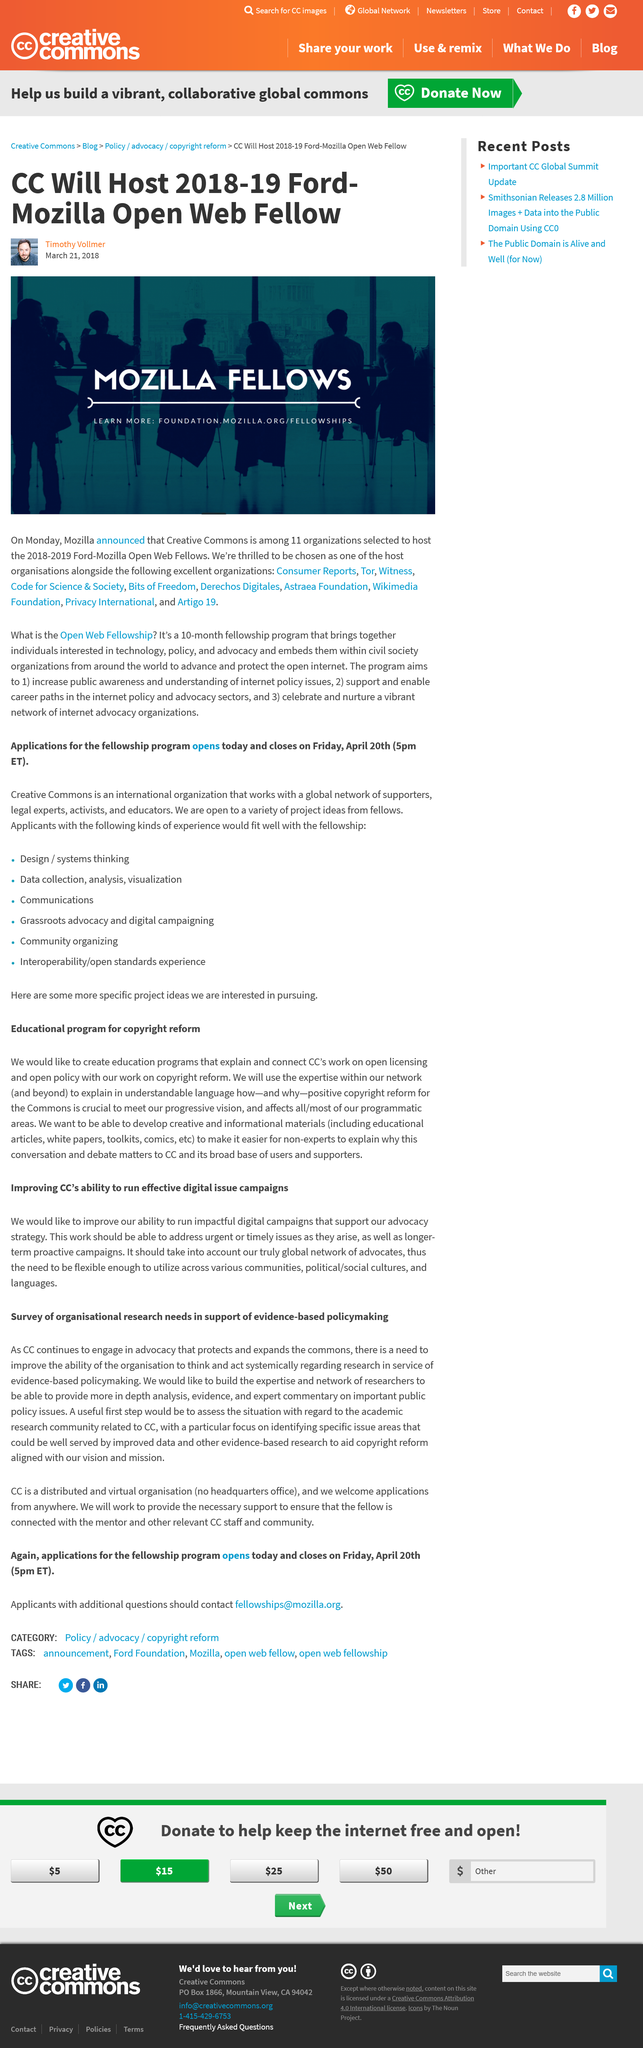Specify some key components in this picture. Creative Commons will host the 2018-2019 Ford-Mozilla Open Web Fellows. We aim to develop a variety of informational materials, including educational articles, white papers, toolkits, and comics, to enhance our clients' knowledge and understanding of various topics. It is recommended that the first useful step in this situation be to assess the academic research community's perspective on CC. The event in question is known as the "2018-2019 Ford Mozilla Open Web Fellow. Timothy Vollmer is the author of this article. 